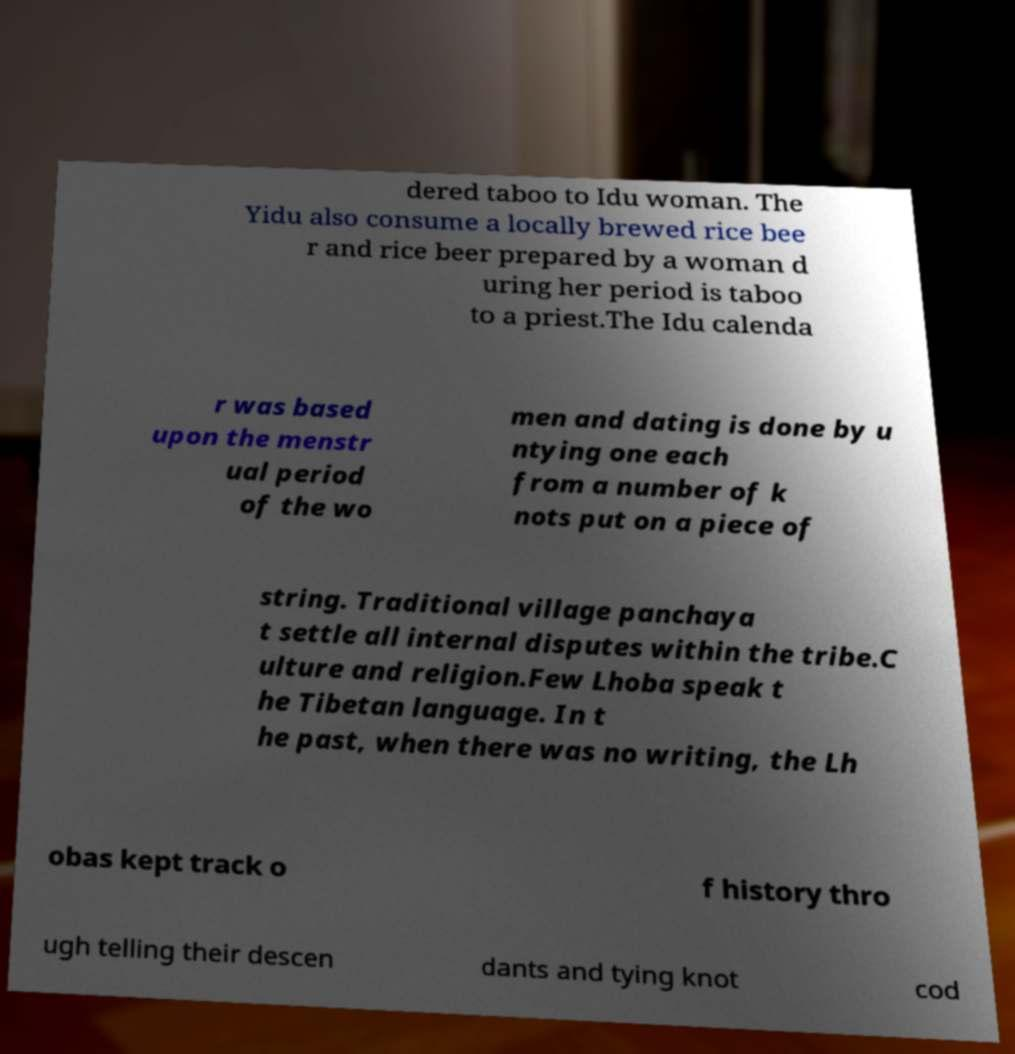Can you accurately transcribe the text from the provided image for me? dered taboo to Idu woman. The Yidu also consume a locally brewed rice bee r and rice beer prepared by a woman d uring her period is taboo to a priest.The Idu calenda r was based upon the menstr ual period of the wo men and dating is done by u ntying one each from a number of k nots put on a piece of string. Traditional village panchaya t settle all internal disputes within the tribe.C ulture and religion.Few Lhoba speak t he Tibetan language. In t he past, when there was no writing, the Lh obas kept track o f history thro ugh telling their descen dants and tying knot cod 